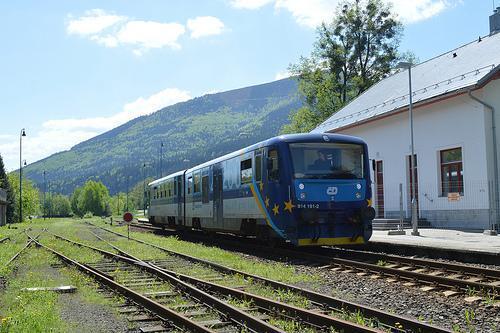How many trains are shown?
Give a very brief answer. 1. 